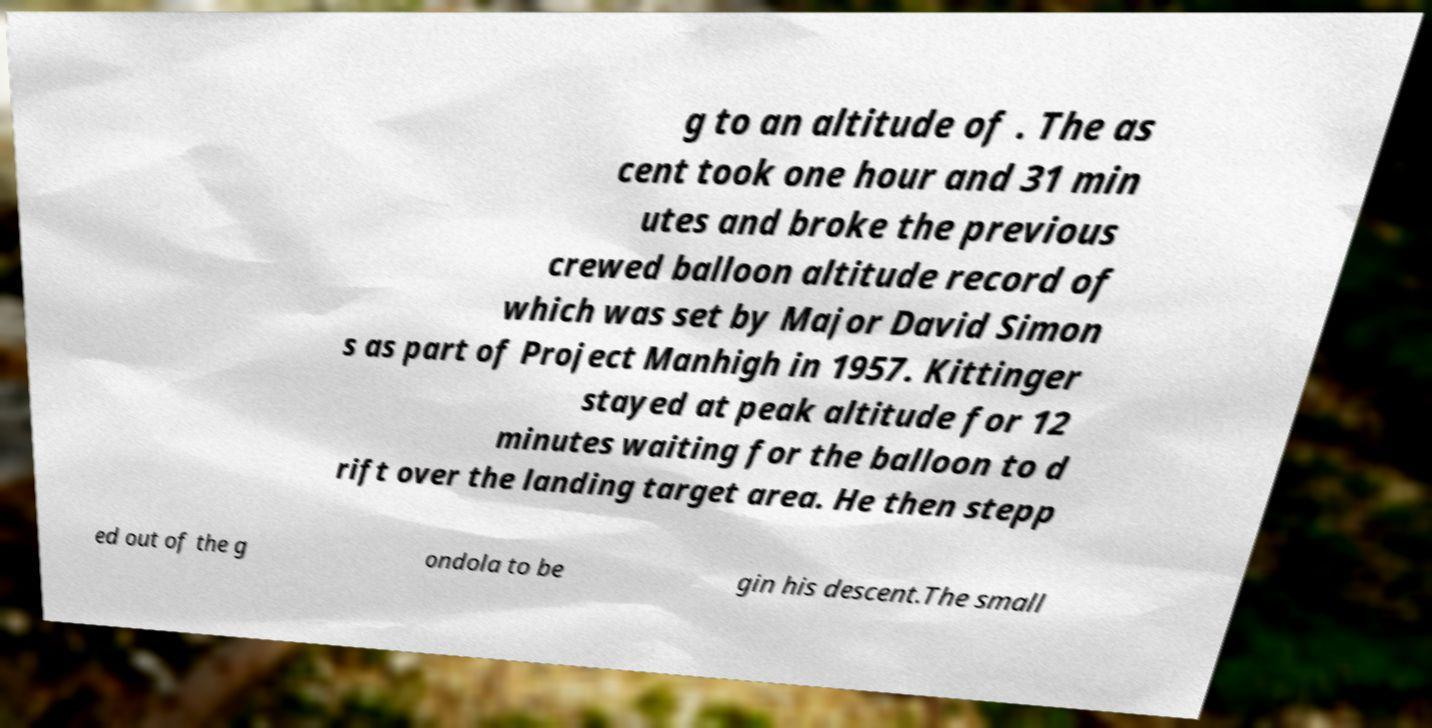Can you accurately transcribe the text from the provided image for me? g to an altitude of . The as cent took one hour and 31 min utes and broke the previous crewed balloon altitude record of which was set by Major David Simon s as part of Project Manhigh in 1957. Kittinger stayed at peak altitude for 12 minutes waiting for the balloon to d rift over the landing target area. He then stepp ed out of the g ondola to be gin his descent.The small 